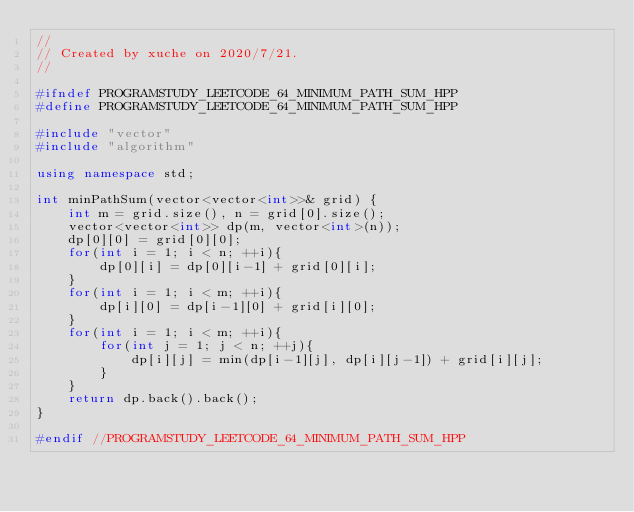<code> <loc_0><loc_0><loc_500><loc_500><_C++_>//
// Created by xuche on 2020/7/21.
//

#ifndef PROGRAMSTUDY_LEETCODE_64_MINIMUM_PATH_SUM_HPP
#define PROGRAMSTUDY_LEETCODE_64_MINIMUM_PATH_SUM_HPP

#include "vector"
#include "algorithm"

using namespace std;

int minPathSum(vector<vector<int>>& grid) {
    int m = grid.size(), n = grid[0].size();
    vector<vector<int>> dp(m, vector<int>(n));
    dp[0][0] = grid[0][0];
    for(int i = 1; i < n; ++i){
        dp[0][i] = dp[0][i-1] + grid[0][i];
    }
    for(int i = 1; i < m; ++i){
        dp[i][0] = dp[i-1][0] + grid[i][0];
    }
    for(int i = 1; i < m; ++i){
        for(int j = 1; j < n; ++j){
            dp[i][j] = min(dp[i-1][j], dp[i][j-1]) + grid[i][j];
        }
    }
    return dp.back().back();
}

#endif //PROGRAMSTUDY_LEETCODE_64_MINIMUM_PATH_SUM_HPP
</code> 